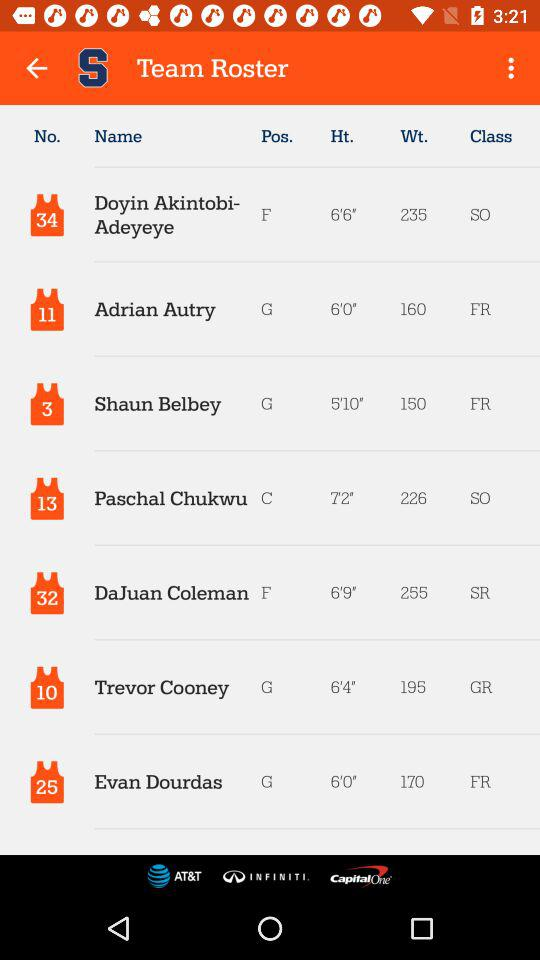What's the height of Shaun Belbey? Shaun Belbey's height is 5'10". 